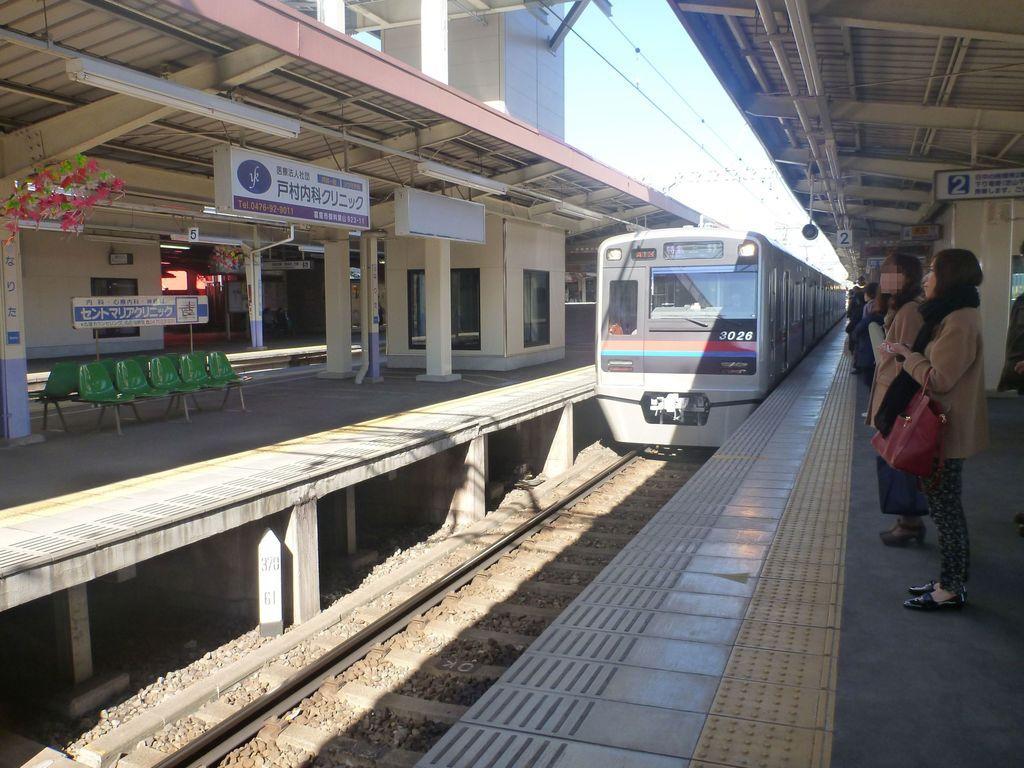In one or two sentences, can you explain what this image depicts? In the middle of the image we can see a train placed on the track. To the right side of the image we can see group of people standing on the ground. One woman is holding a bag in her hand. To the left side of the image we can see group of chairs placed on the ground ,several sign boards and in the background we can see the sky. 